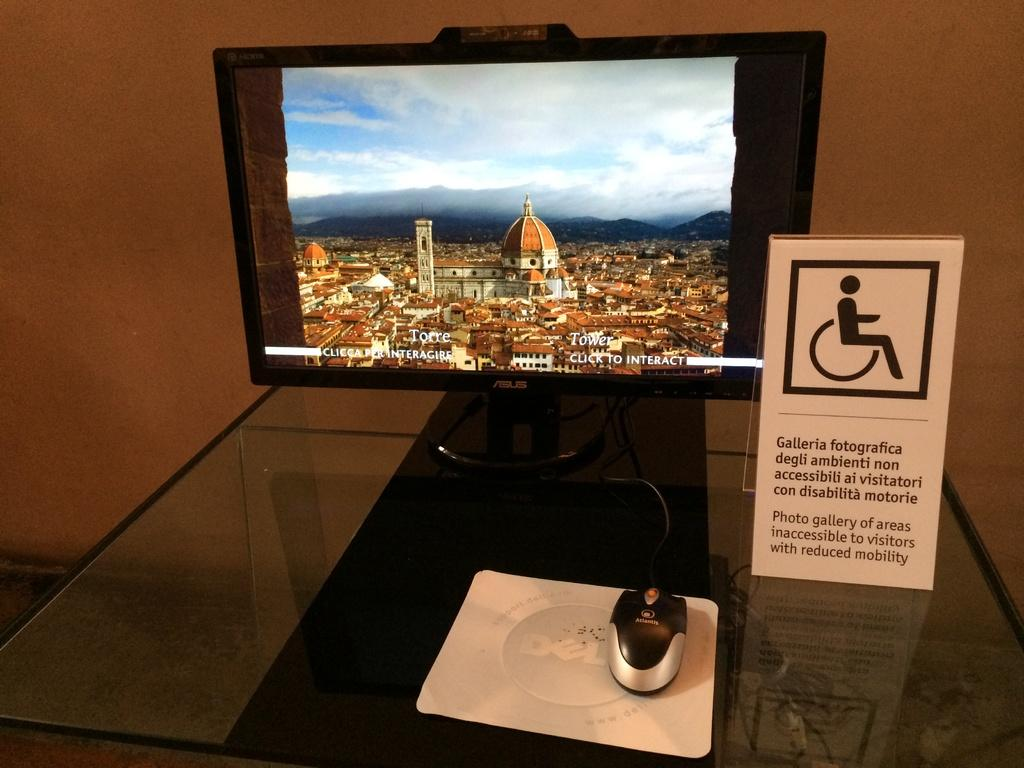Provide a one-sentence caption for the provided image. a handicap sign with galleria on  the front. 